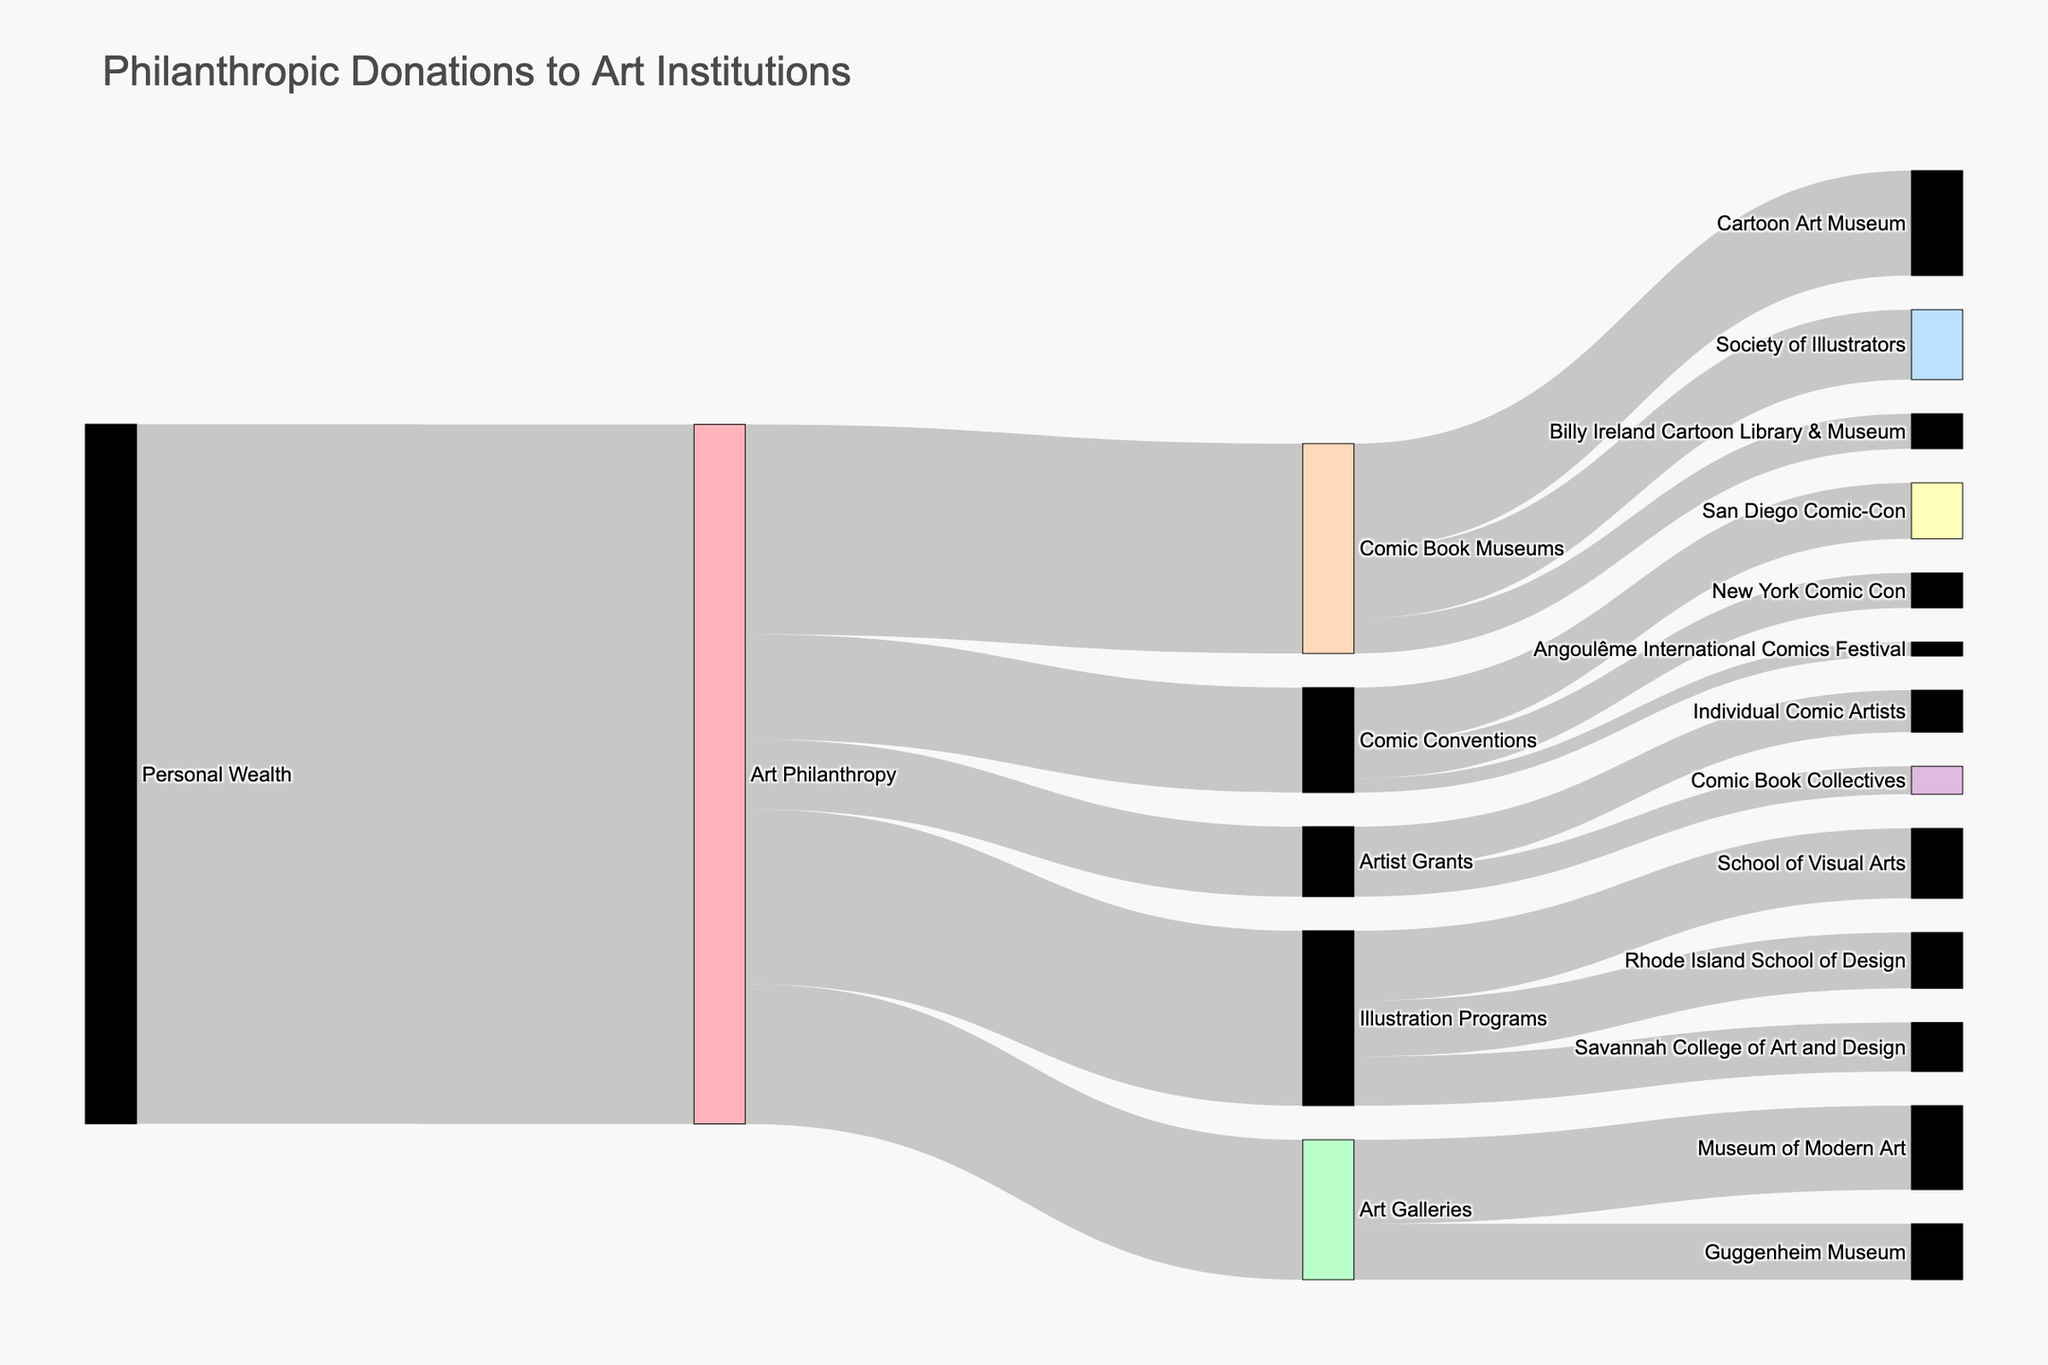what is the total amount allocated to Comic Book Museums? In the Sankey Diagram, the link between "Art Philanthropy" and "Comic Book Museums" shows a donation value of $3,000,000, which represents the total amount allocated to Comic Book Museums.
Answer: $3,000,000 How does the amount allocated to Comic Conventions compare to the amount allocated to Artist Grants? Comic Conventions receive $1,500,000 while Artist Grants receive $1,000,000. We see the direct allocations from "Art Philanthropy" in the diagram. $1,000,000 is less than $1,500,000, so Comic Conventions receive more.
Answer: Comic Conventions receive more What is the combined total received by the Cartoon Art Museum and the Society of Illustrators? The Sankey Diagram shows that the Cartoon Art Museum receives $1,500,000 and the Society of Illustrators receives $1,000,000. By adding these values, we get $1,500,000 + $1,000,000 = $2,500,000.
Answer: $2,500,000 Which receives more funding: San Diego Comic-Con or New York Comic Con? According to the diagram, San Diego Comic-Con receives $800,000 while New York Comic Con receives $500,000. Therefore, San Diego Comic-Con receives more funding.
Answer: San Diego Comic-Con How much more funding does the School of Visual Arts receive compared to the Savannah College of Art and Design? The School of Visual Arts receives $1,000,000 while the Savannah College of Art and Design receives $700,000. The difference is $1,000,000 - $700,000 = $300,000.
Answer: $300,000 more What is the smallest allocation from "Art Philanthropy" and to which Target does it go? The smallest allocation from "Art Philanthropy" is $500,000, which goes to the "Billy Ireland Cartoon Library & Museum." This can be seen by looking at the connection lines and values in the diagram.
Answer: Billy Ireland Cartoon Library & Museum What is the total amount allocated to all Art Galleries combined? The diagram shows the allocations to the Museum of Modern Art ($1,200,000) and the Guggenheim Museum ($800,000). Adding these together gives $1,200,000 + $800,000 = $2,000,000.
Answer: $2,000,000 How much total funding is directed toward comic book-related initiatives (Comic Book Museums, Comic Conventions, and Artist Grants focusing on comic artists)? Adding the values directed to Comic Book Museums ($3,000,000), Comic Conventions ($1,500,000), and the Artist Grants allocated to comic artists ($600,000), we get $3,000,000 + $1,500,000 + $600,000 = $5,100,000.
Answer: $5,100,000 Which receives a higher amount: Individual Comic Artists through grants or the Angoulême International Comics Festival? Individual Comic Artists receive $600,000 through Artist Grants, while the Angoulême International Comics Festival receives $200,000 through Comic Conventions. Therefore, Individual Comic Artists receive a higher amount.
Answer: Individual Comic Artists 